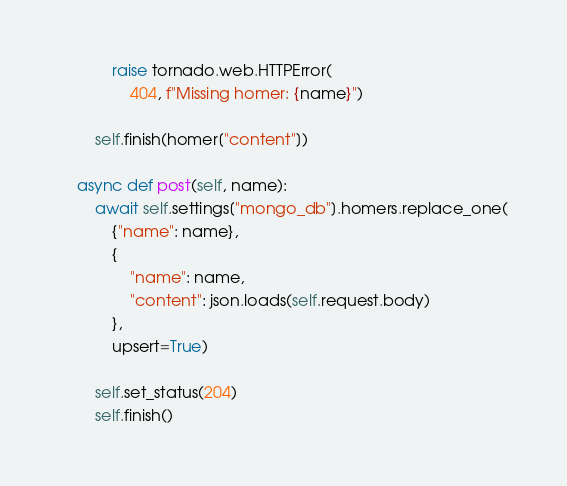Convert code to text. <code><loc_0><loc_0><loc_500><loc_500><_Python_>            raise tornado.web.HTTPError(
                404, f"Missing homer: {name}")

        self.finish(homer["content"])

    async def post(self, name):
        await self.settings["mongo_db"].homers.replace_one(
            {"name": name},
            {
                "name": name,
                "content": json.loads(self.request.body)
            },
            upsert=True)

        self.set_status(204)
        self.finish()
</code> 